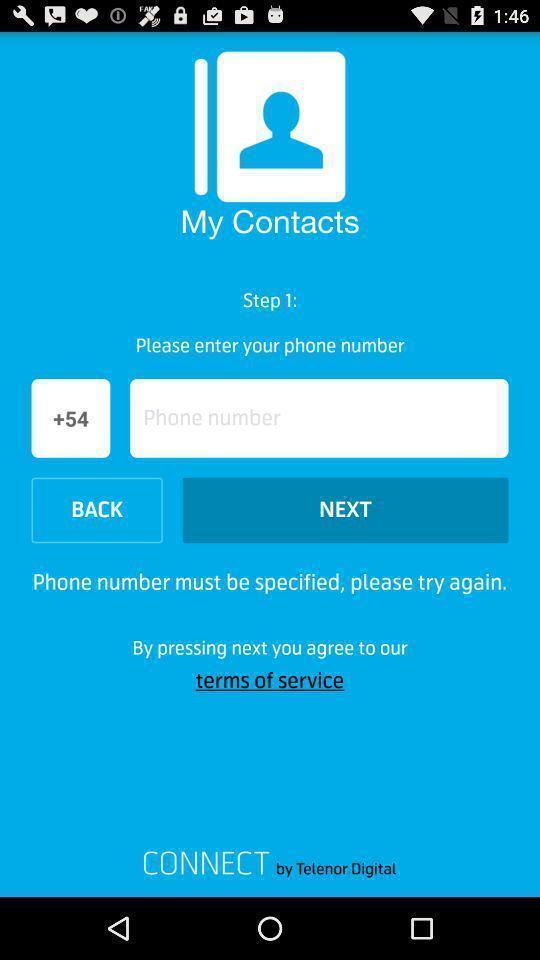Summarize the information in this screenshot. Screen shows data about a contacts app. 